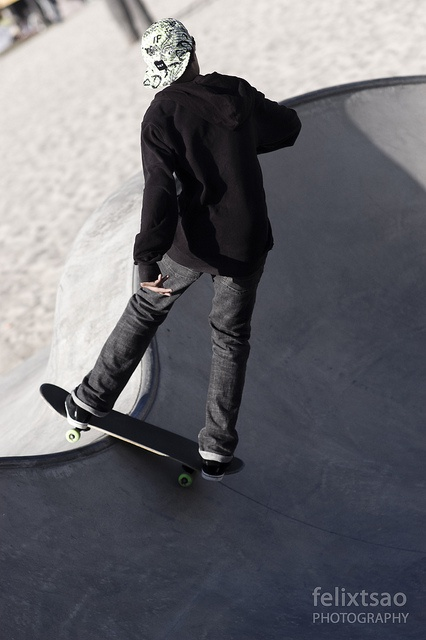Describe the objects in this image and their specific colors. I can see people in ivory, black, gray, lightgray, and darkgray tones and skateboard in beige, black, lightgray, gray, and darkgray tones in this image. 